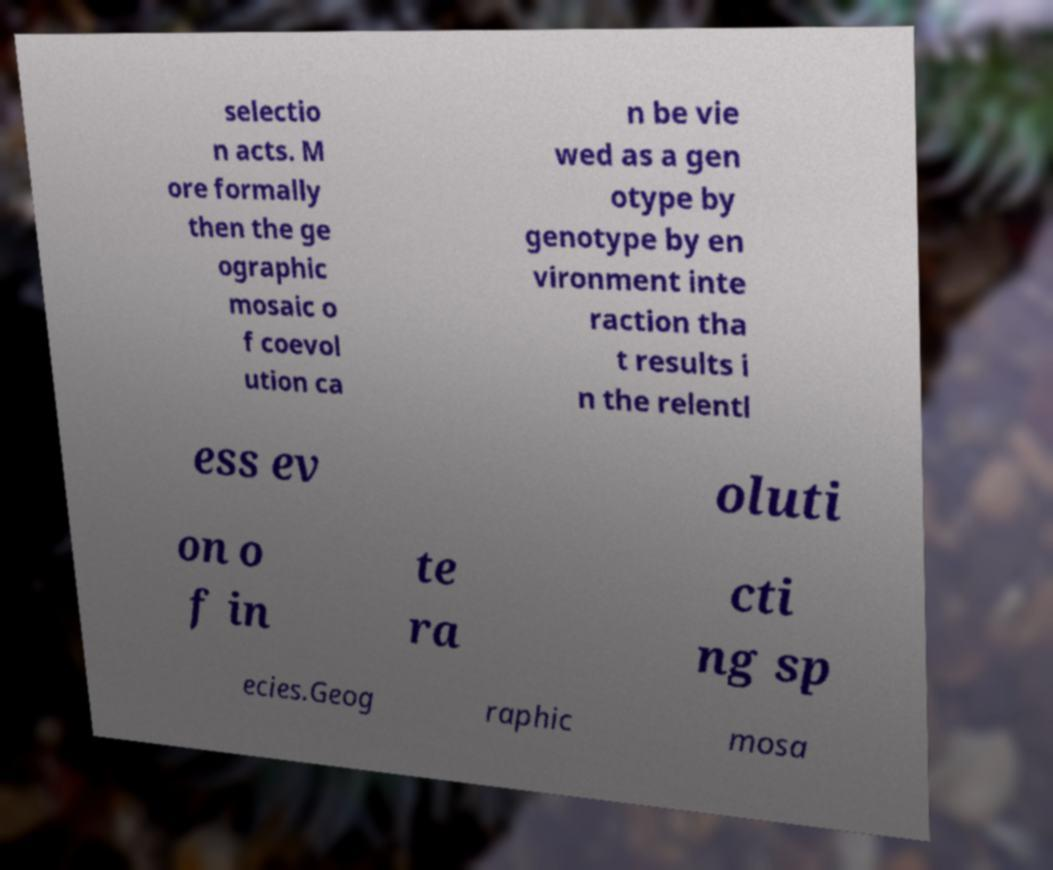For documentation purposes, I need the text within this image transcribed. Could you provide that? selectio n acts. M ore formally then the ge ographic mosaic o f coevol ution ca n be vie wed as a gen otype by genotype by en vironment inte raction tha t results i n the relentl ess ev oluti on o f in te ra cti ng sp ecies.Geog raphic mosa 